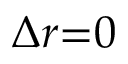<formula> <loc_0><loc_0><loc_500><loc_500>\Delta { r } { = } 0</formula> 